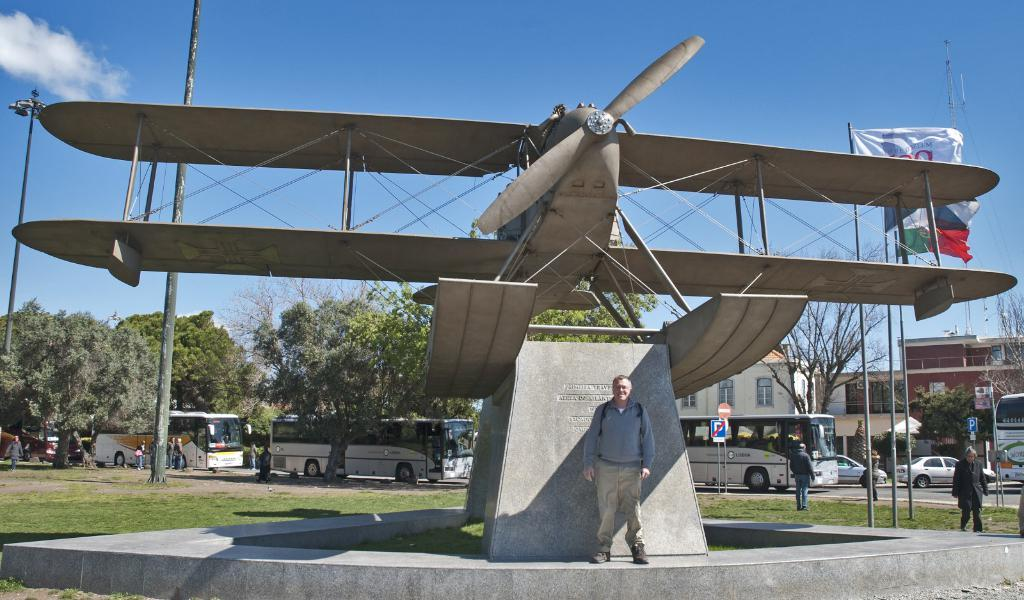What is the main subject in the center of the image? There is a sculpture in the center of the image. Can you describe the people in the image? There are people in the image, but their specific actions or positions are not mentioned in the facts. What can be seen on the road in the image? Vehicles are visible on the road. What is visible in the background of the image? There are trees, buildings, and the sky visible in the background of the image. What else can be seen in the image? There are poles in the image. What type of pear is hanging from the pole in the image? There is no pear present in the image; only a sculpture, people, vehicles, trees, buildings, the sky, and poles are mentioned in the facts. What channel is being broadcasted on the television in the image? There is no television present in the image, so it is not possible to determine what channel might be broadcasted. 